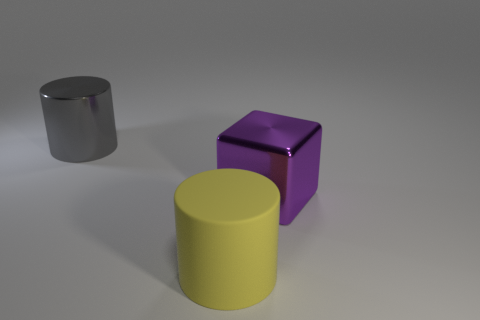Add 3 large things. How many objects exist? 6 Subtract 1 cubes. How many cubes are left? 0 Subtract all cylinders. How many objects are left? 1 Subtract all yellow blocks. How many blue cylinders are left? 0 Subtract all yellow objects. Subtract all cylinders. How many objects are left? 0 Add 2 gray cylinders. How many gray cylinders are left? 3 Add 1 large matte cylinders. How many large matte cylinders exist? 2 Subtract 0 purple cylinders. How many objects are left? 3 Subtract all yellow cylinders. Subtract all green balls. How many cylinders are left? 1 